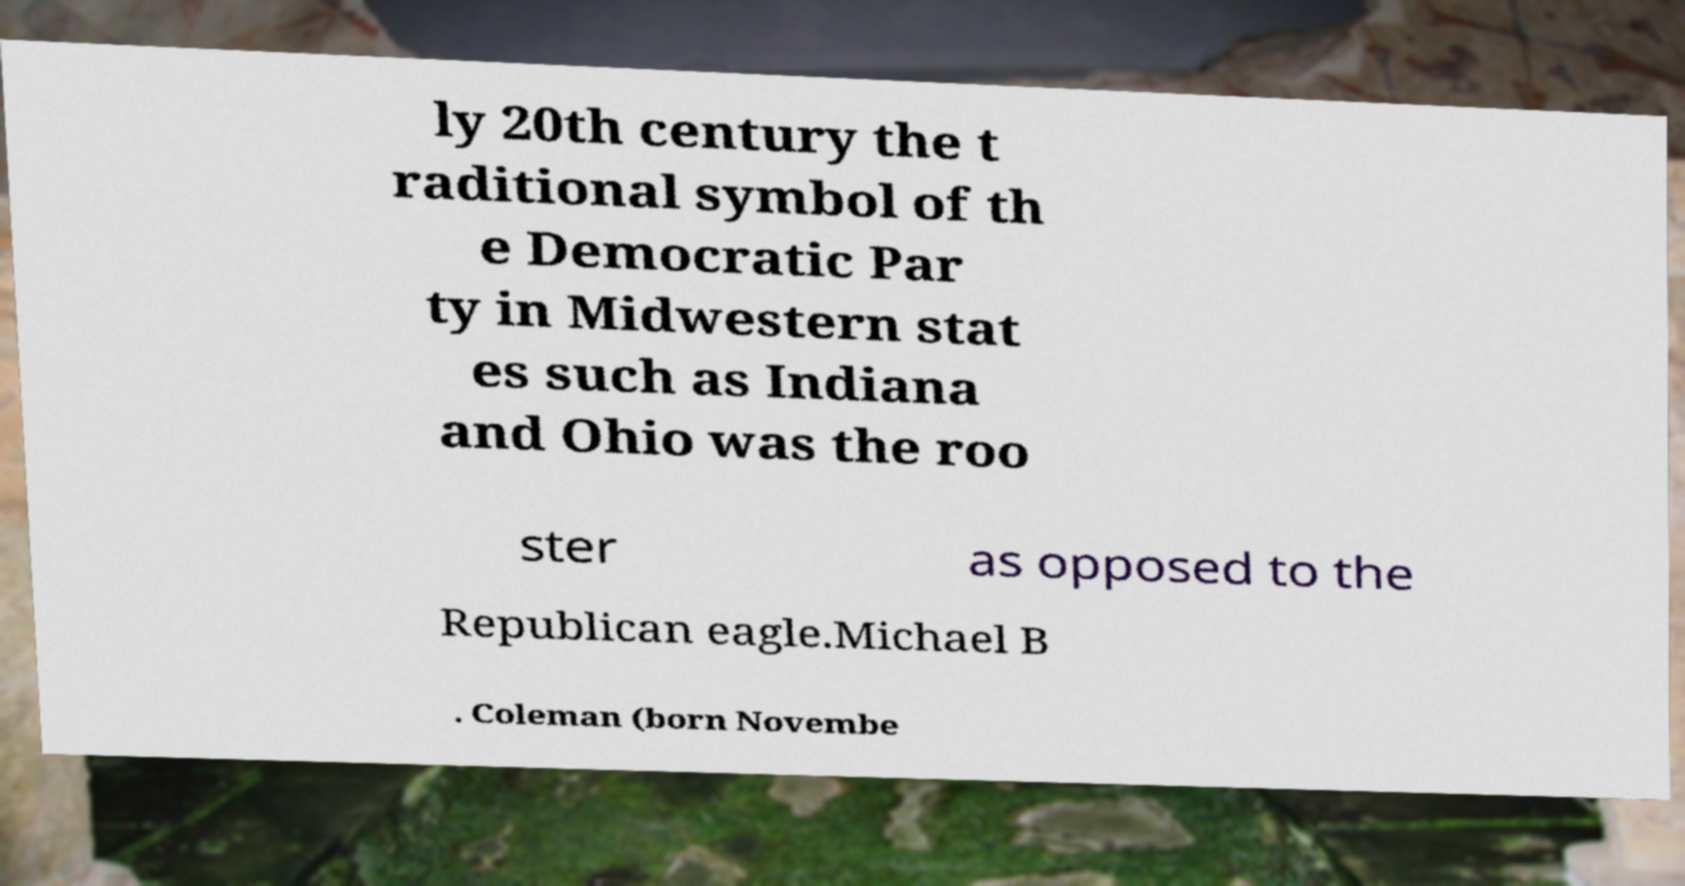Please identify and transcribe the text found in this image. ly 20th century the t raditional symbol of th e Democratic Par ty in Midwestern stat es such as Indiana and Ohio was the roo ster as opposed to the Republican eagle.Michael B . Coleman (born Novembe 